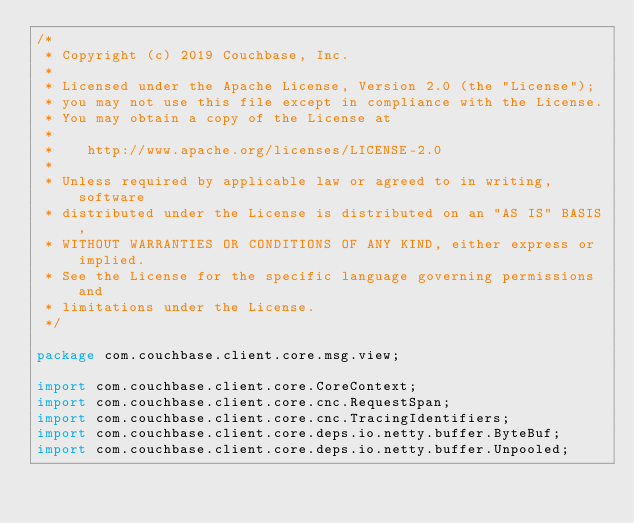<code> <loc_0><loc_0><loc_500><loc_500><_Java_>/*
 * Copyright (c) 2019 Couchbase, Inc.
 *
 * Licensed under the Apache License, Version 2.0 (the "License");
 * you may not use this file except in compliance with the License.
 * You may obtain a copy of the License at
 *
 *    http://www.apache.org/licenses/LICENSE-2.0
 *
 * Unless required by applicable law or agreed to in writing, software
 * distributed under the License is distributed on an "AS IS" BASIS,
 * WITHOUT WARRANTIES OR CONDITIONS OF ANY KIND, either express or implied.
 * See the License for the specific language governing permissions and
 * limitations under the License.
 */

package com.couchbase.client.core.msg.view;

import com.couchbase.client.core.CoreContext;
import com.couchbase.client.core.cnc.RequestSpan;
import com.couchbase.client.core.cnc.TracingIdentifiers;
import com.couchbase.client.core.deps.io.netty.buffer.ByteBuf;
import com.couchbase.client.core.deps.io.netty.buffer.Unpooled;</code> 